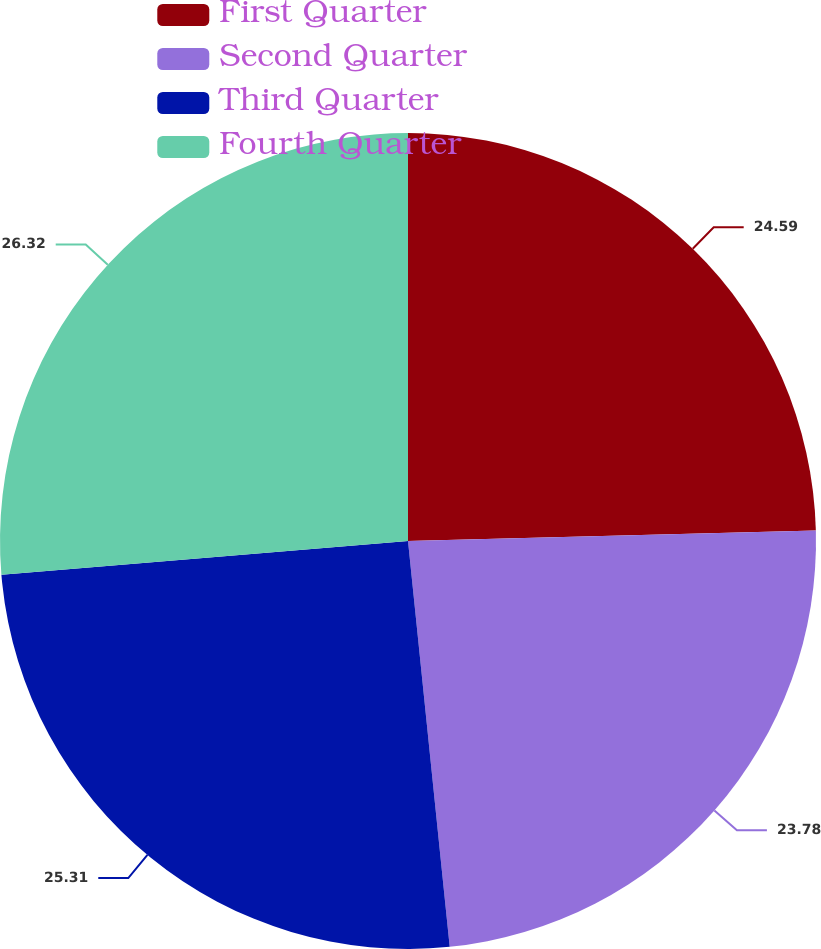Convert chart to OTSL. <chart><loc_0><loc_0><loc_500><loc_500><pie_chart><fcel>First Quarter<fcel>Second Quarter<fcel>Third Quarter<fcel>Fourth Quarter<nl><fcel>24.59%<fcel>23.78%<fcel>25.31%<fcel>26.32%<nl></chart> 